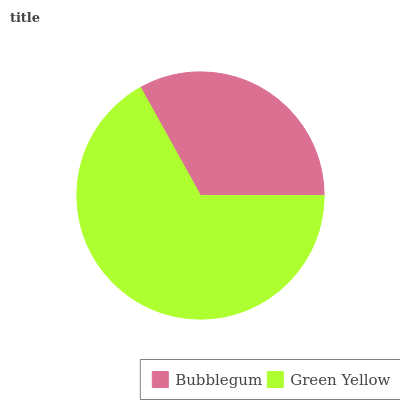Is Bubblegum the minimum?
Answer yes or no. Yes. Is Green Yellow the maximum?
Answer yes or no. Yes. Is Green Yellow the minimum?
Answer yes or no. No. Is Green Yellow greater than Bubblegum?
Answer yes or no. Yes. Is Bubblegum less than Green Yellow?
Answer yes or no. Yes. Is Bubblegum greater than Green Yellow?
Answer yes or no. No. Is Green Yellow less than Bubblegum?
Answer yes or no. No. Is Green Yellow the high median?
Answer yes or no. Yes. Is Bubblegum the low median?
Answer yes or no. Yes. Is Bubblegum the high median?
Answer yes or no. No. Is Green Yellow the low median?
Answer yes or no. No. 